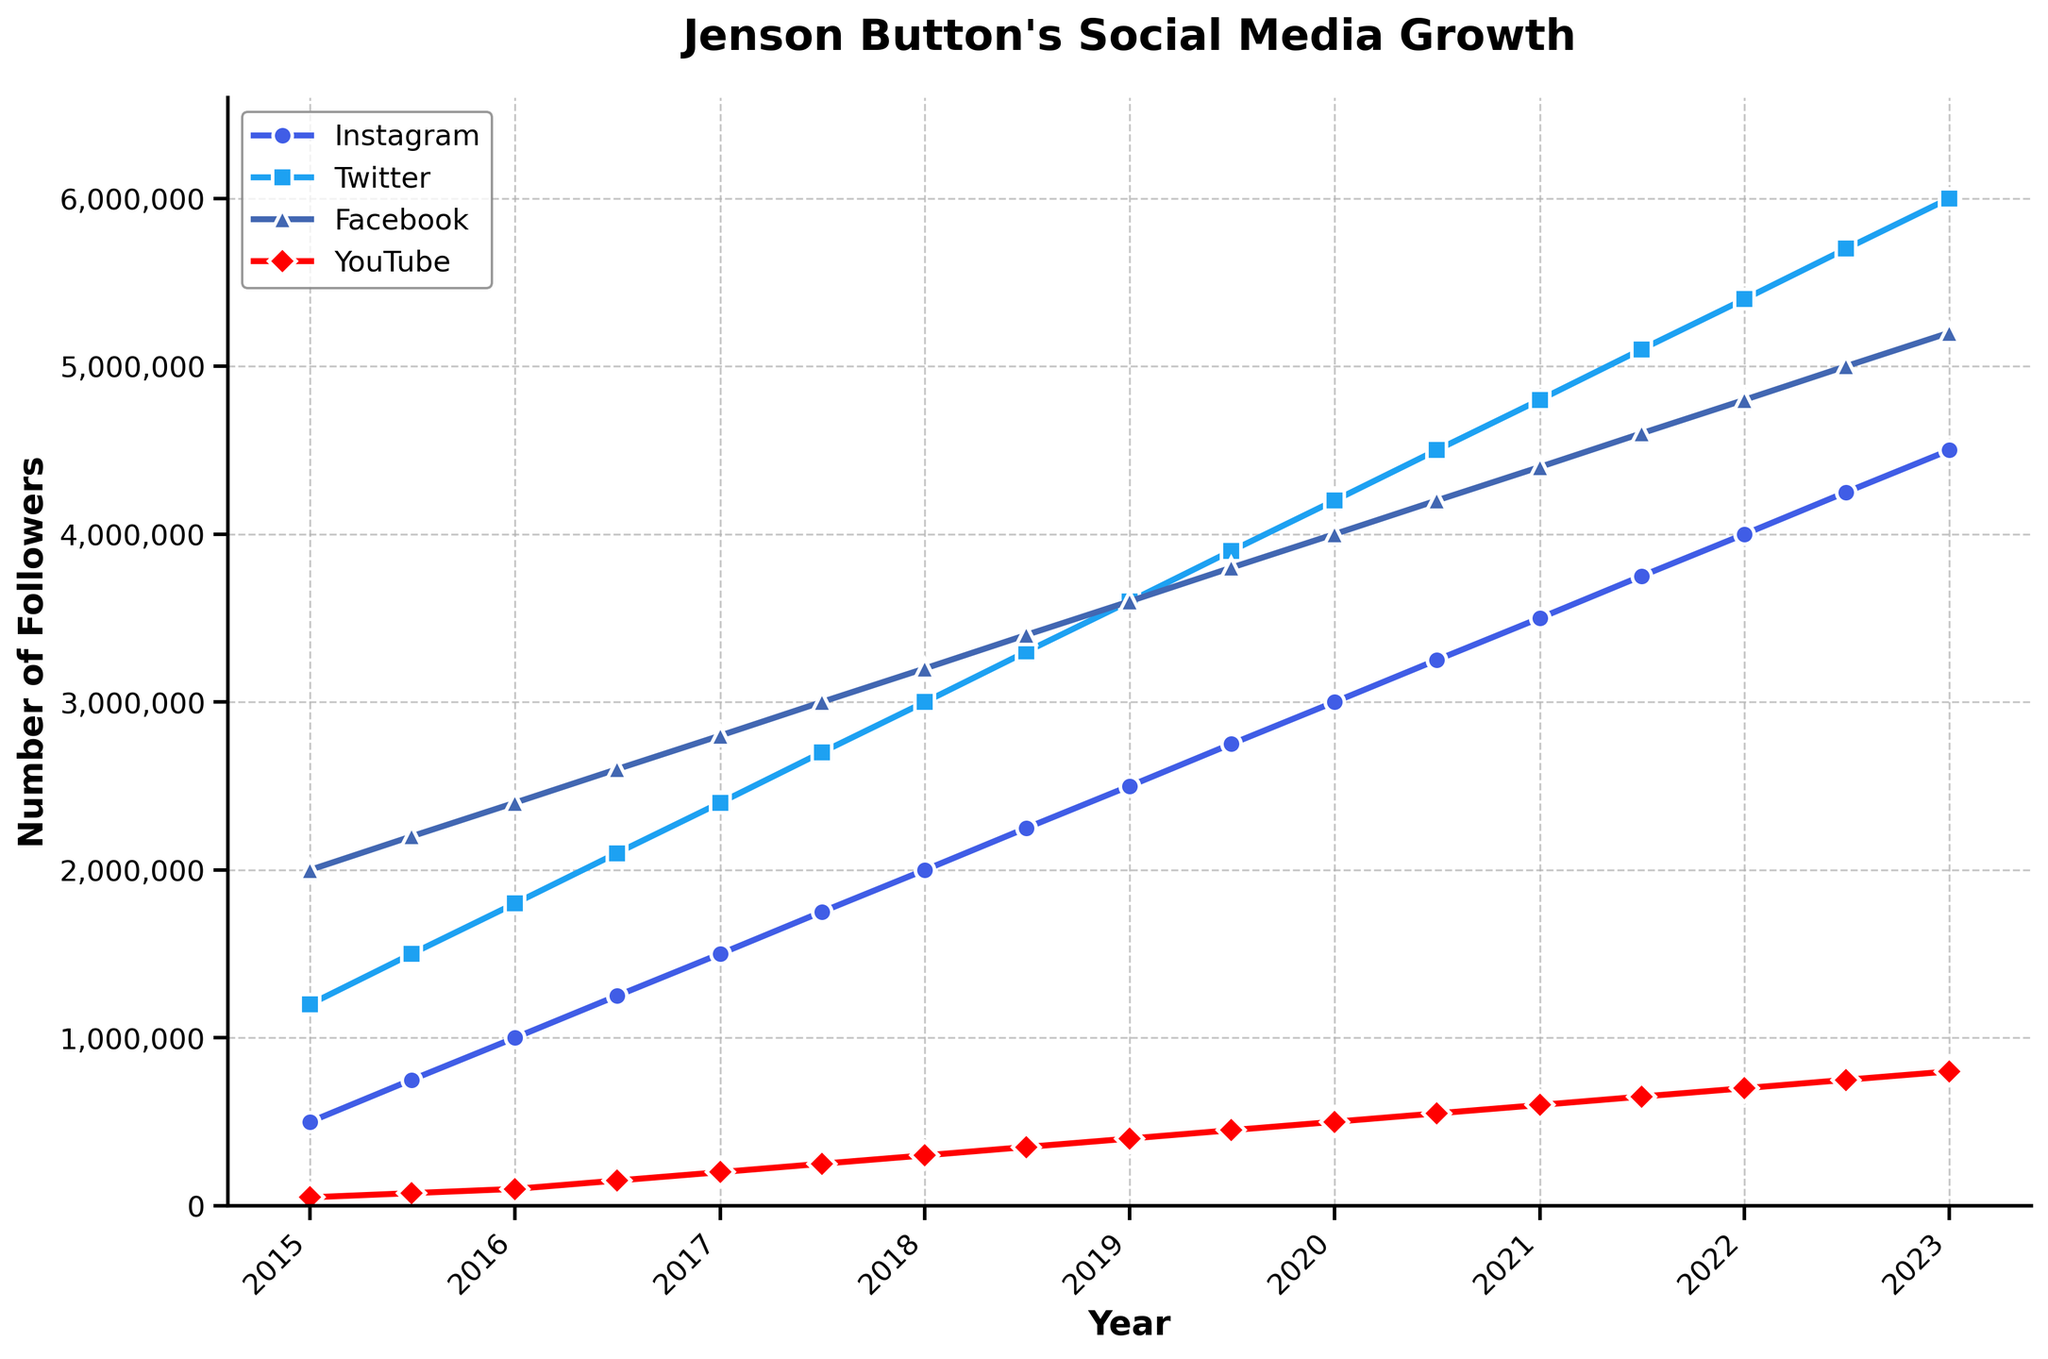Which social media platform had the highest followers in 2023? To find this, look at the values on the right end of the lines in the figure, corresponding to the year 2023. Compare the four platforms: Instagram, Twitter, Facebook, and YouTube. Twitter has the highest value.
Answer: Twitter By how much did Jenson Button's Instagram followers increase from 2015 to 2023? Look at the Instagram follower count for the start and end dates. In 2015 it was 500,000, and in 2023 it was 4,500,000. Subtract to find the difference: 4,500,000 - 500,000.
Answer: 4,000,000 In which year did Jenson Button's YouTube followers reach 600,000? Observe the YouTube follower count line and find where it intersects the value of 600,000. According to the line, this was achieved in 2021.
Answer: 2021 What is the average number of Facebook followers in 2017? Identify the number of followers at the two data points in 2017, which are 2,800,000 (Jan) and 3,000,000 (Jul). Add these values together and divide by 2 for the average: (2,800,000 + 3,000,000) / 2.
Answer: 2,900,000 Which platform had the steepest increase in followers between any two consecutive dates? Look for the steepest slope visually on the graph between any two consecutive date points. Twitter's line from 2018 to 2022 appears the steepest due to a sharp incline.
Answer: Twitter How many followers did Jenson Button have on YouTube compared to Facebook in 2020? Look at both the YouTube and Facebook follower counts for the year 2020. In January, YouTube has 500,000 and Facebook has 4,000,000. In July, YouTube has 550,000 and Facebook has 4,200,000. Comparing the two in any of these periods, Facebook's count is consistently higher.
Answer: Facebook had significantly more followers Which platform saw the smallest growth in followers from 2015 to 2023? Calculate the total increase for each platform. Instagram: 4,500,000 - 500,000 = 4,000,000. Twitter: 6,000,000 - 1,200,000 = 4,800,000. Facebook: 5,200,000 - 2,000,000 = 3,200,000. YouTube: 800,000 - 50,000 = 750,000. YouTube saw the smallest growth.
Answer: YouTube Did Jenson Button's Twitter followers ever exceed 5 million? Look at the Twitter follower line and see whether it crosses the 5 million mark. The figure indicates it surpasses 5 million around 2022.
Answer: Yes Which year marked a significant milestone of 1 million followers for Jenson Button's Instagram? Observe the line for Instagram and identify the year it reaches 1 million. It intersects at around the start of 2016.
Answer: 2016 